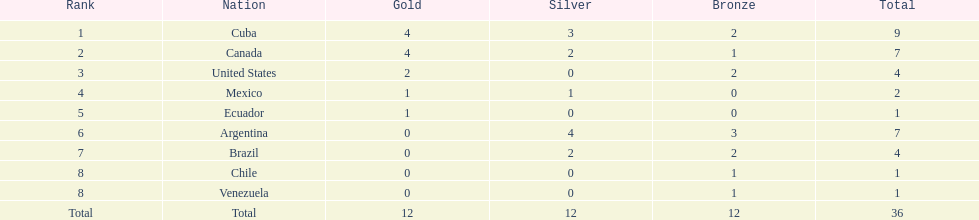Which country secured the gold medal but failed to obtain silver? United States. 